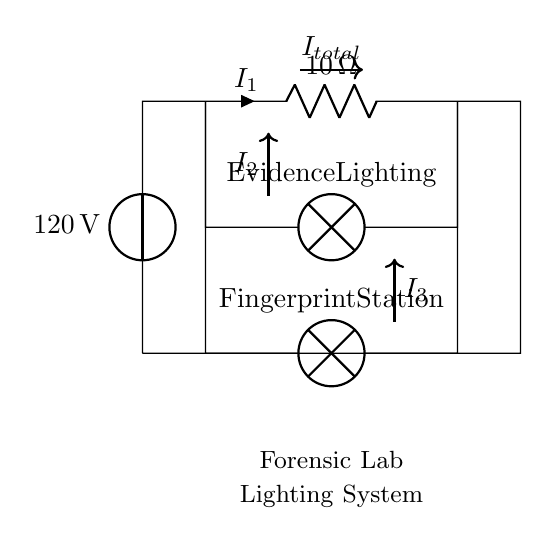What is the total voltage supplied in the circuit? The total voltage supplied is 120 volts, which is indicated by the voltage source label in the circuit diagram.
Answer: 120 volts What type of circuit is represented in the diagram? The circuit is a parallel circuit, as seen from the two lamps that are connected in parallel to the same voltage source.
Answer: Parallel How many lamps are there in the circuit? There are two lamps in the circuit, labeled as Evidence Lighting and Fingerprint Station, both connected in parallel to the voltage source.
Answer: Two What is the resistance of the resistor in the circuit? The resistor in the circuit has a resistance of 10 ohms, as marked next to the resistor symbol in the diagram.
Answer: 10 ohms What are the individual currents through each lamp? To determine the individual currents, you need to consider the voltage across each lamp (120 volts) and use Ohm's law. Each lamp will have the same voltage and the current can be derived depending on the resistance of each lamp if specified. However, the circuit does not specify the resistance of the lamps, so I cannot determine the exact current through each lamp.
Answer: Not specified What can you say about the current distribution in this parallel circuit? In a parallel circuit, the total current splits among the branches. Each branch will have a different current based on the resistance of the components in that branch according to the current divider rule. Since the lamps' resistances are not provided, individual currents cannot be calculated but will total the supplied current from the source.
Answer: Splits among branches 